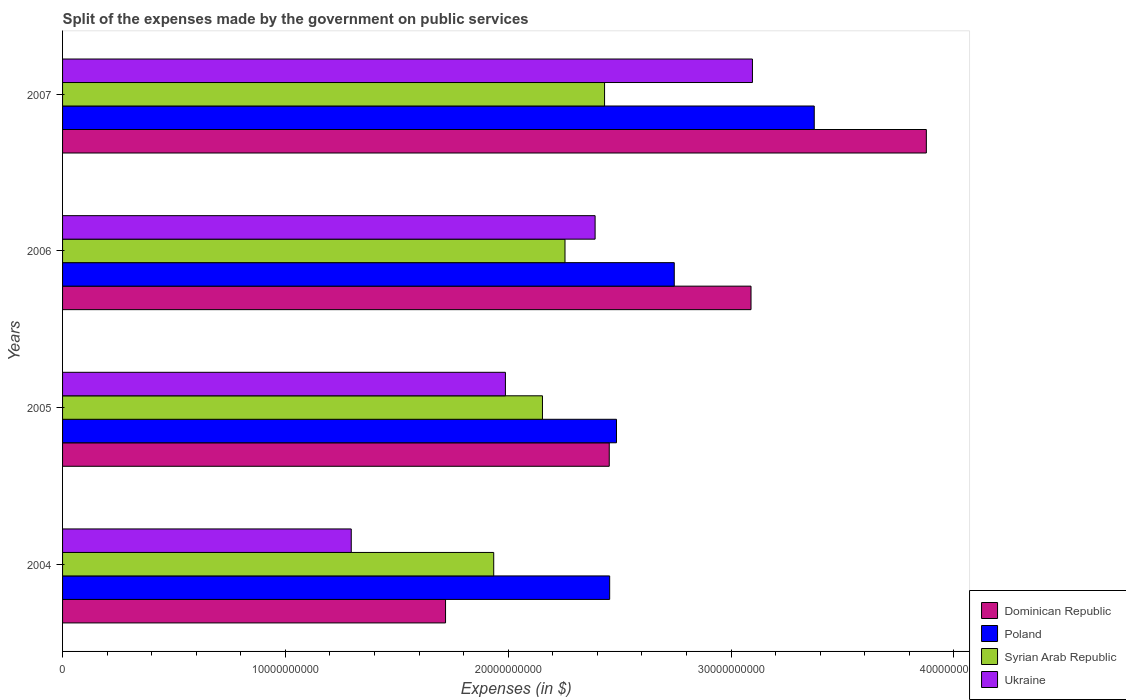Are the number of bars on each tick of the Y-axis equal?
Offer a very short reply. Yes. How many bars are there on the 2nd tick from the top?
Your answer should be compact. 4. What is the label of the 3rd group of bars from the top?
Your answer should be compact. 2005. What is the expenses made by the government on public services in Dominican Republic in 2004?
Offer a very short reply. 1.72e+1. Across all years, what is the maximum expenses made by the government on public services in Syrian Arab Republic?
Provide a succinct answer. 2.43e+1. Across all years, what is the minimum expenses made by the government on public services in Syrian Arab Republic?
Give a very brief answer. 1.93e+1. In which year was the expenses made by the government on public services in Dominican Republic minimum?
Keep it short and to the point. 2004. What is the total expenses made by the government on public services in Ukraine in the graph?
Offer a terse response. 8.77e+1. What is the difference between the expenses made by the government on public services in Dominican Republic in 2004 and that in 2006?
Offer a terse response. -1.37e+1. What is the difference between the expenses made by the government on public services in Syrian Arab Republic in 2006 and the expenses made by the government on public services in Ukraine in 2007?
Your answer should be compact. -8.41e+09. What is the average expenses made by the government on public services in Dominican Republic per year?
Offer a terse response. 2.78e+1. In the year 2004, what is the difference between the expenses made by the government on public services in Poland and expenses made by the government on public services in Dominican Republic?
Ensure brevity in your answer.  7.36e+09. In how many years, is the expenses made by the government on public services in Syrian Arab Republic greater than 34000000000 $?
Make the answer very short. 0. What is the ratio of the expenses made by the government on public services in Poland in 2004 to that in 2006?
Provide a succinct answer. 0.89. Is the expenses made by the government on public services in Poland in 2005 less than that in 2007?
Give a very brief answer. Yes. What is the difference between the highest and the second highest expenses made by the government on public services in Ukraine?
Ensure brevity in your answer.  7.06e+09. What is the difference between the highest and the lowest expenses made by the government on public services in Ukraine?
Offer a terse response. 1.80e+1. In how many years, is the expenses made by the government on public services in Ukraine greater than the average expenses made by the government on public services in Ukraine taken over all years?
Your response must be concise. 2. Is the sum of the expenses made by the government on public services in Poland in 2004 and 2007 greater than the maximum expenses made by the government on public services in Dominican Republic across all years?
Offer a very short reply. Yes. What does the 3rd bar from the bottom in 2006 represents?
Your response must be concise. Syrian Arab Republic. How many bars are there?
Your response must be concise. 16. How many years are there in the graph?
Your answer should be compact. 4. Does the graph contain any zero values?
Ensure brevity in your answer.  No. How are the legend labels stacked?
Your answer should be compact. Vertical. What is the title of the graph?
Your response must be concise. Split of the expenses made by the government on public services. Does "Marshall Islands" appear as one of the legend labels in the graph?
Your answer should be compact. No. What is the label or title of the X-axis?
Offer a terse response. Expenses (in $). What is the label or title of the Y-axis?
Offer a terse response. Years. What is the Expenses (in $) of Dominican Republic in 2004?
Provide a succinct answer. 1.72e+1. What is the Expenses (in $) of Poland in 2004?
Offer a very short reply. 2.46e+1. What is the Expenses (in $) in Syrian Arab Republic in 2004?
Provide a short and direct response. 1.93e+1. What is the Expenses (in $) of Ukraine in 2004?
Give a very brief answer. 1.30e+1. What is the Expenses (in $) in Dominican Republic in 2005?
Your response must be concise. 2.45e+1. What is the Expenses (in $) in Poland in 2005?
Keep it short and to the point. 2.49e+1. What is the Expenses (in $) of Syrian Arab Republic in 2005?
Keep it short and to the point. 2.15e+1. What is the Expenses (in $) in Ukraine in 2005?
Offer a very short reply. 1.99e+1. What is the Expenses (in $) in Dominican Republic in 2006?
Your answer should be very brief. 3.09e+1. What is the Expenses (in $) of Poland in 2006?
Your response must be concise. 2.74e+1. What is the Expenses (in $) in Syrian Arab Republic in 2006?
Offer a very short reply. 2.25e+1. What is the Expenses (in $) of Ukraine in 2006?
Make the answer very short. 2.39e+1. What is the Expenses (in $) of Dominican Republic in 2007?
Offer a terse response. 3.88e+1. What is the Expenses (in $) in Poland in 2007?
Provide a short and direct response. 3.37e+1. What is the Expenses (in $) of Syrian Arab Republic in 2007?
Provide a short and direct response. 2.43e+1. What is the Expenses (in $) in Ukraine in 2007?
Provide a succinct answer. 3.10e+1. Across all years, what is the maximum Expenses (in $) of Dominican Republic?
Offer a terse response. 3.88e+1. Across all years, what is the maximum Expenses (in $) of Poland?
Your answer should be compact. 3.37e+1. Across all years, what is the maximum Expenses (in $) in Syrian Arab Republic?
Offer a very short reply. 2.43e+1. Across all years, what is the maximum Expenses (in $) of Ukraine?
Your response must be concise. 3.10e+1. Across all years, what is the minimum Expenses (in $) in Dominican Republic?
Provide a short and direct response. 1.72e+1. Across all years, what is the minimum Expenses (in $) of Poland?
Keep it short and to the point. 2.46e+1. Across all years, what is the minimum Expenses (in $) in Syrian Arab Republic?
Keep it short and to the point. 1.93e+1. Across all years, what is the minimum Expenses (in $) in Ukraine?
Make the answer very short. 1.30e+1. What is the total Expenses (in $) of Dominican Republic in the graph?
Provide a succinct answer. 1.11e+11. What is the total Expenses (in $) in Poland in the graph?
Ensure brevity in your answer.  1.11e+11. What is the total Expenses (in $) in Syrian Arab Republic in the graph?
Ensure brevity in your answer.  8.77e+1. What is the total Expenses (in $) of Ukraine in the graph?
Offer a terse response. 8.77e+1. What is the difference between the Expenses (in $) in Dominican Republic in 2004 and that in 2005?
Your answer should be very brief. -7.35e+09. What is the difference between the Expenses (in $) of Poland in 2004 and that in 2005?
Offer a terse response. -3.07e+08. What is the difference between the Expenses (in $) in Syrian Arab Republic in 2004 and that in 2005?
Provide a succinct answer. -2.19e+09. What is the difference between the Expenses (in $) in Ukraine in 2004 and that in 2005?
Your answer should be compact. -6.92e+09. What is the difference between the Expenses (in $) in Dominican Republic in 2004 and that in 2006?
Ensure brevity in your answer.  -1.37e+1. What is the difference between the Expenses (in $) of Poland in 2004 and that in 2006?
Offer a very short reply. -2.90e+09. What is the difference between the Expenses (in $) in Syrian Arab Republic in 2004 and that in 2006?
Your answer should be very brief. -3.20e+09. What is the difference between the Expenses (in $) in Ukraine in 2004 and that in 2006?
Your response must be concise. -1.09e+1. What is the difference between the Expenses (in $) of Dominican Republic in 2004 and that in 2007?
Make the answer very short. -2.16e+1. What is the difference between the Expenses (in $) of Poland in 2004 and that in 2007?
Provide a short and direct response. -9.18e+09. What is the difference between the Expenses (in $) of Syrian Arab Republic in 2004 and that in 2007?
Make the answer very short. -4.97e+09. What is the difference between the Expenses (in $) of Ukraine in 2004 and that in 2007?
Offer a very short reply. -1.80e+1. What is the difference between the Expenses (in $) in Dominican Republic in 2005 and that in 2006?
Provide a succinct answer. -6.36e+09. What is the difference between the Expenses (in $) in Poland in 2005 and that in 2006?
Provide a succinct answer. -2.59e+09. What is the difference between the Expenses (in $) of Syrian Arab Republic in 2005 and that in 2006?
Make the answer very short. -1.01e+09. What is the difference between the Expenses (in $) of Ukraine in 2005 and that in 2006?
Your response must be concise. -4.02e+09. What is the difference between the Expenses (in $) of Dominican Republic in 2005 and that in 2007?
Your answer should be compact. -1.42e+1. What is the difference between the Expenses (in $) in Poland in 2005 and that in 2007?
Offer a terse response. -8.87e+09. What is the difference between the Expenses (in $) of Syrian Arab Republic in 2005 and that in 2007?
Provide a short and direct response. -2.79e+09. What is the difference between the Expenses (in $) in Ukraine in 2005 and that in 2007?
Make the answer very short. -1.11e+1. What is the difference between the Expenses (in $) of Dominican Republic in 2006 and that in 2007?
Offer a very short reply. -7.87e+09. What is the difference between the Expenses (in $) in Poland in 2006 and that in 2007?
Your answer should be compact. -6.28e+09. What is the difference between the Expenses (in $) in Syrian Arab Republic in 2006 and that in 2007?
Ensure brevity in your answer.  -1.78e+09. What is the difference between the Expenses (in $) of Ukraine in 2006 and that in 2007?
Your answer should be compact. -7.06e+09. What is the difference between the Expenses (in $) in Dominican Republic in 2004 and the Expenses (in $) in Poland in 2005?
Give a very brief answer. -7.67e+09. What is the difference between the Expenses (in $) in Dominican Republic in 2004 and the Expenses (in $) in Syrian Arab Republic in 2005?
Provide a short and direct response. -4.35e+09. What is the difference between the Expenses (in $) in Dominican Republic in 2004 and the Expenses (in $) in Ukraine in 2005?
Offer a terse response. -2.69e+09. What is the difference between the Expenses (in $) of Poland in 2004 and the Expenses (in $) of Syrian Arab Republic in 2005?
Your answer should be very brief. 3.02e+09. What is the difference between the Expenses (in $) of Poland in 2004 and the Expenses (in $) of Ukraine in 2005?
Your answer should be compact. 4.68e+09. What is the difference between the Expenses (in $) of Syrian Arab Republic in 2004 and the Expenses (in $) of Ukraine in 2005?
Ensure brevity in your answer.  -5.26e+08. What is the difference between the Expenses (in $) in Dominican Republic in 2004 and the Expenses (in $) in Poland in 2006?
Make the answer very short. -1.03e+1. What is the difference between the Expenses (in $) of Dominican Republic in 2004 and the Expenses (in $) of Syrian Arab Republic in 2006?
Offer a terse response. -5.36e+09. What is the difference between the Expenses (in $) of Dominican Republic in 2004 and the Expenses (in $) of Ukraine in 2006?
Offer a very short reply. -6.71e+09. What is the difference between the Expenses (in $) in Poland in 2004 and the Expenses (in $) in Syrian Arab Republic in 2006?
Give a very brief answer. 2.00e+09. What is the difference between the Expenses (in $) of Poland in 2004 and the Expenses (in $) of Ukraine in 2006?
Provide a short and direct response. 6.53e+08. What is the difference between the Expenses (in $) of Syrian Arab Republic in 2004 and the Expenses (in $) of Ukraine in 2006?
Make the answer very short. -4.55e+09. What is the difference between the Expenses (in $) in Dominican Republic in 2004 and the Expenses (in $) in Poland in 2007?
Ensure brevity in your answer.  -1.65e+1. What is the difference between the Expenses (in $) in Dominican Republic in 2004 and the Expenses (in $) in Syrian Arab Republic in 2007?
Your answer should be compact. -7.14e+09. What is the difference between the Expenses (in $) of Dominican Republic in 2004 and the Expenses (in $) of Ukraine in 2007?
Make the answer very short. -1.38e+1. What is the difference between the Expenses (in $) of Poland in 2004 and the Expenses (in $) of Syrian Arab Republic in 2007?
Your answer should be compact. 2.29e+08. What is the difference between the Expenses (in $) of Poland in 2004 and the Expenses (in $) of Ukraine in 2007?
Your answer should be compact. -6.41e+09. What is the difference between the Expenses (in $) in Syrian Arab Republic in 2004 and the Expenses (in $) in Ukraine in 2007?
Give a very brief answer. -1.16e+1. What is the difference between the Expenses (in $) in Dominican Republic in 2005 and the Expenses (in $) in Poland in 2006?
Keep it short and to the point. -2.92e+09. What is the difference between the Expenses (in $) of Dominican Republic in 2005 and the Expenses (in $) of Syrian Arab Republic in 2006?
Ensure brevity in your answer.  1.99e+09. What is the difference between the Expenses (in $) in Dominican Republic in 2005 and the Expenses (in $) in Ukraine in 2006?
Your answer should be compact. 6.35e+08. What is the difference between the Expenses (in $) of Poland in 2005 and the Expenses (in $) of Syrian Arab Republic in 2006?
Keep it short and to the point. 2.31e+09. What is the difference between the Expenses (in $) in Poland in 2005 and the Expenses (in $) in Ukraine in 2006?
Your response must be concise. 9.60e+08. What is the difference between the Expenses (in $) in Syrian Arab Republic in 2005 and the Expenses (in $) in Ukraine in 2006?
Ensure brevity in your answer.  -2.36e+09. What is the difference between the Expenses (in $) of Dominican Republic in 2005 and the Expenses (in $) of Poland in 2007?
Provide a succinct answer. -9.20e+09. What is the difference between the Expenses (in $) in Dominican Republic in 2005 and the Expenses (in $) in Syrian Arab Republic in 2007?
Provide a succinct answer. 2.11e+08. What is the difference between the Expenses (in $) in Dominican Republic in 2005 and the Expenses (in $) in Ukraine in 2007?
Offer a very short reply. -6.42e+09. What is the difference between the Expenses (in $) of Poland in 2005 and the Expenses (in $) of Syrian Arab Republic in 2007?
Provide a short and direct response. 5.36e+08. What is the difference between the Expenses (in $) of Poland in 2005 and the Expenses (in $) of Ukraine in 2007?
Your answer should be compact. -6.10e+09. What is the difference between the Expenses (in $) in Syrian Arab Republic in 2005 and the Expenses (in $) in Ukraine in 2007?
Offer a terse response. -9.42e+09. What is the difference between the Expenses (in $) in Dominican Republic in 2006 and the Expenses (in $) in Poland in 2007?
Offer a very short reply. -2.84e+09. What is the difference between the Expenses (in $) in Dominican Republic in 2006 and the Expenses (in $) in Syrian Arab Republic in 2007?
Your answer should be very brief. 6.57e+09. What is the difference between the Expenses (in $) of Dominican Republic in 2006 and the Expenses (in $) of Ukraine in 2007?
Provide a short and direct response. -6.32e+07. What is the difference between the Expenses (in $) in Poland in 2006 and the Expenses (in $) in Syrian Arab Republic in 2007?
Keep it short and to the point. 3.13e+09. What is the difference between the Expenses (in $) of Poland in 2006 and the Expenses (in $) of Ukraine in 2007?
Provide a succinct answer. -3.51e+09. What is the difference between the Expenses (in $) of Syrian Arab Republic in 2006 and the Expenses (in $) of Ukraine in 2007?
Provide a short and direct response. -8.41e+09. What is the average Expenses (in $) in Dominican Republic per year?
Offer a terse response. 2.78e+1. What is the average Expenses (in $) of Poland per year?
Your answer should be compact. 2.76e+1. What is the average Expenses (in $) in Syrian Arab Republic per year?
Keep it short and to the point. 2.19e+1. What is the average Expenses (in $) in Ukraine per year?
Offer a terse response. 2.19e+1. In the year 2004, what is the difference between the Expenses (in $) in Dominican Republic and Expenses (in $) in Poland?
Offer a very short reply. -7.36e+09. In the year 2004, what is the difference between the Expenses (in $) of Dominican Republic and Expenses (in $) of Syrian Arab Republic?
Your response must be concise. -2.16e+09. In the year 2004, what is the difference between the Expenses (in $) in Dominican Republic and Expenses (in $) in Ukraine?
Provide a succinct answer. 4.23e+09. In the year 2004, what is the difference between the Expenses (in $) of Poland and Expenses (in $) of Syrian Arab Republic?
Provide a succinct answer. 5.20e+09. In the year 2004, what is the difference between the Expenses (in $) of Poland and Expenses (in $) of Ukraine?
Your response must be concise. 1.16e+1. In the year 2004, what is the difference between the Expenses (in $) in Syrian Arab Republic and Expenses (in $) in Ukraine?
Your answer should be compact. 6.39e+09. In the year 2005, what is the difference between the Expenses (in $) of Dominican Republic and Expenses (in $) of Poland?
Your answer should be compact. -3.25e+08. In the year 2005, what is the difference between the Expenses (in $) of Dominican Republic and Expenses (in $) of Syrian Arab Republic?
Give a very brief answer. 3.00e+09. In the year 2005, what is the difference between the Expenses (in $) in Dominican Republic and Expenses (in $) in Ukraine?
Your answer should be compact. 4.66e+09. In the year 2005, what is the difference between the Expenses (in $) of Poland and Expenses (in $) of Syrian Arab Republic?
Your answer should be compact. 3.32e+09. In the year 2005, what is the difference between the Expenses (in $) of Poland and Expenses (in $) of Ukraine?
Ensure brevity in your answer.  4.98e+09. In the year 2005, what is the difference between the Expenses (in $) of Syrian Arab Republic and Expenses (in $) of Ukraine?
Your answer should be compact. 1.66e+09. In the year 2006, what is the difference between the Expenses (in $) of Dominican Republic and Expenses (in $) of Poland?
Offer a very short reply. 3.44e+09. In the year 2006, what is the difference between the Expenses (in $) in Dominican Republic and Expenses (in $) in Syrian Arab Republic?
Provide a short and direct response. 8.35e+09. In the year 2006, what is the difference between the Expenses (in $) in Dominican Republic and Expenses (in $) in Ukraine?
Provide a succinct answer. 7.00e+09. In the year 2006, what is the difference between the Expenses (in $) of Poland and Expenses (in $) of Syrian Arab Republic?
Offer a terse response. 4.90e+09. In the year 2006, what is the difference between the Expenses (in $) in Poland and Expenses (in $) in Ukraine?
Keep it short and to the point. 3.55e+09. In the year 2006, what is the difference between the Expenses (in $) in Syrian Arab Republic and Expenses (in $) in Ukraine?
Your response must be concise. -1.35e+09. In the year 2007, what is the difference between the Expenses (in $) of Dominican Republic and Expenses (in $) of Poland?
Your response must be concise. 5.03e+09. In the year 2007, what is the difference between the Expenses (in $) of Dominican Republic and Expenses (in $) of Syrian Arab Republic?
Ensure brevity in your answer.  1.44e+1. In the year 2007, what is the difference between the Expenses (in $) in Dominican Republic and Expenses (in $) in Ukraine?
Your answer should be compact. 7.80e+09. In the year 2007, what is the difference between the Expenses (in $) of Poland and Expenses (in $) of Syrian Arab Republic?
Give a very brief answer. 9.41e+09. In the year 2007, what is the difference between the Expenses (in $) in Poland and Expenses (in $) in Ukraine?
Offer a very short reply. 2.77e+09. In the year 2007, what is the difference between the Expenses (in $) of Syrian Arab Republic and Expenses (in $) of Ukraine?
Your response must be concise. -6.64e+09. What is the ratio of the Expenses (in $) of Dominican Republic in 2004 to that in 2005?
Ensure brevity in your answer.  0.7. What is the ratio of the Expenses (in $) in Poland in 2004 to that in 2005?
Give a very brief answer. 0.99. What is the ratio of the Expenses (in $) in Syrian Arab Republic in 2004 to that in 2005?
Give a very brief answer. 0.9. What is the ratio of the Expenses (in $) in Ukraine in 2004 to that in 2005?
Provide a succinct answer. 0.65. What is the ratio of the Expenses (in $) of Dominican Republic in 2004 to that in 2006?
Give a very brief answer. 0.56. What is the ratio of the Expenses (in $) of Poland in 2004 to that in 2006?
Offer a terse response. 0.89. What is the ratio of the Expenses (in $) of Syrian Arab Republic in 2004 to that in 2006?
Ensure brevity in your answer.  0.86. What is the ratio of the Expenses (in $) of Ukraine in 2004 to that in 2006?
Offer a very short reply. 0.54. What is the ratio of the Expenses (in $) in Dominican Republic in 2004 to that in 2007?
Your response must be concise. 0.44. What is the ratio of the Expenses (in $) of Poland in 2004 to that in 2007?
Give a very brief answer. 0.73. What is the ratio of the Expenses (in $) of Syrian Arab Republic in 2004 to that in 2007?
Provide a succinct answer. 0.8. What is the ratio of the Expenses (in $) of Ukraine in 2004 to that in 2007?
Keep it short and to the point. 0.42. What is the ratio of the Expenses (in $) in Dominican Republic in 2005 to that in 2006?
Your answer should be compact. 0.79. What is the ratio of the Expenses (in $) in Poland in 2005 to that in 2006?
Provide a succinct answer. 0.91. What is the ratio of the Expenses (in $) of Syrian Arab Republic in 2005 to that in 2006?
Give a very brief answer. 0.96. What is the ratio of the Expenses (in $) in Ukraine in 2005 to that in 2006?
Make the answer very short. 0.83. What is the ratio of the Expenses (in $) in Dominican Republic in 2005 to that in 2007?
Provide a succinct answer. 0.63. What is the ratio of the Expenses (in $) in Poland in 2005 to that in 2007?
Your response must be concise. 0.74. What is the ratio of the Expenses (in $) of Syrian Arab Republic in 2005 to that in 2007?
Offer a terse response. 0.89. What is the ratio of the Expenses (in $) of Ukraine in 2005 to that in 2007?
Make the answer very short. 0.64. What is the ratio of the Expenses (in $) in Dominican Republic in 2006 to that in 2007?
Provide a short and direct response. 0.8. What is the ratio of the Expenses (in $) of Poland in 2006 to that in 2007?
Your answer should be compact. 0.81. What is the ratio of the Expenses (in $) in Syrian Arab Republic in 2006 to that in 2007?
Offer a terse response. 0.93. What is the ratio of the Expenses (in $) of Ukraine in 2006 to that in 2007?
Your answer should be compact. 0.77. What is the difference between the highest and the second highest Expenses (in $) in Dominican Republic?
Offer a terse response. 7.87e+09. What is the difference between the highest and the second highest Expenses (in $) in Poland?
Keep it short and to the point. 6.28e+09. What is the difference between the highest and the second highest Expenses (in $) in Syrian Arab Republic?
Keep it short and to the point. 1.78e+09. What is the difference between the highest and the second highest Expenses (in $) in Ukraine?
Ensure brevity in your answer.  7.06e+09. What is the difference between the highest and the lowest Expenses (in $) of Dominican Republic?
Provide a short and direct response. 2.16e+1. What is the difference between the highest and the lowest Expenses (in $) in Poland?
Offer a terse response. 9.18e+09. What is the difference between the highest and the lowest Expenses (in $) of Syrian Arab Republic?
Your response must be concise. 4.97e+09. What is the difference between the highest and the lowest Expenses (in $) of Ukraine?
Ensure brevity in your answer.  1.80e+1. 